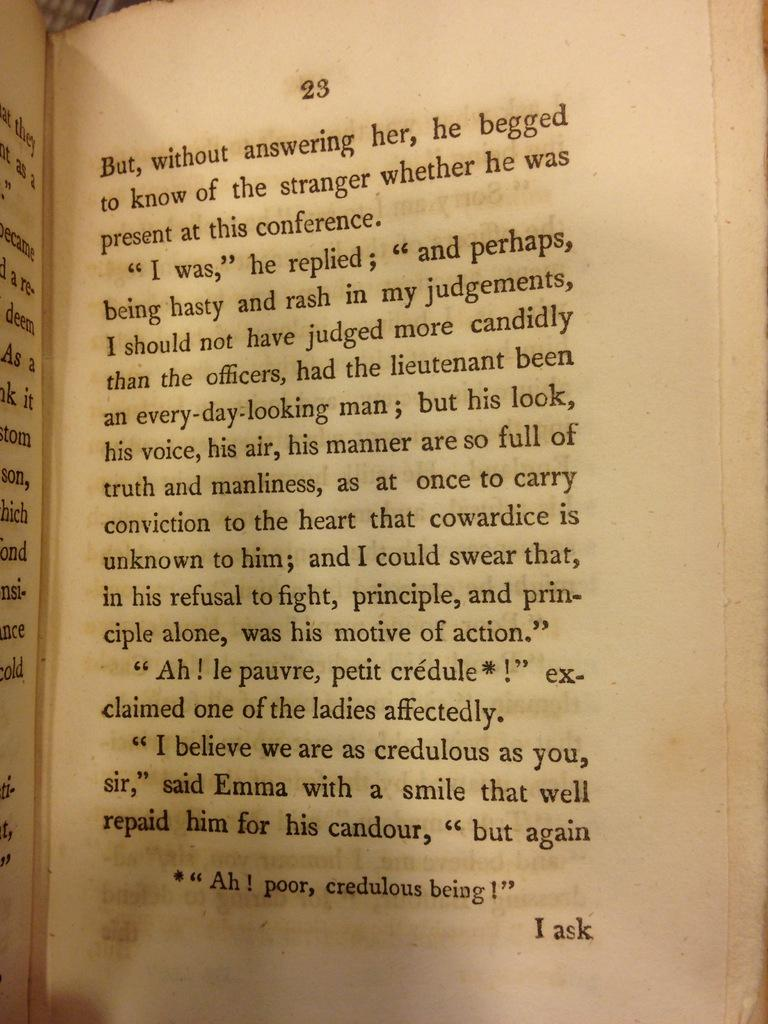Provide a one-sentence caption for the provided image. A book open to page 23 that says I ask on the bottom. 